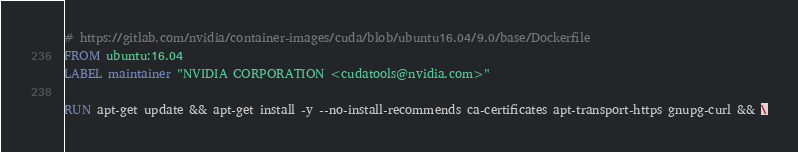Convert code to text. <code><loc_0><loc_0><loc_500><loc_500><_Dockerfile_># https://gitlab.com/nvidia/container-images/cuda/blob/ubuntu16.04/9.0/base/Dockerfile
FROM ubuntu:16.04
LABEL maintainer "NVIDIA CORPORATION <cudatools@nvidia.com>"

RUN apt-get update && apt-get install -y --no-install-recommends ca-certificates apt-transport-https gnupg-curl && \</code> 